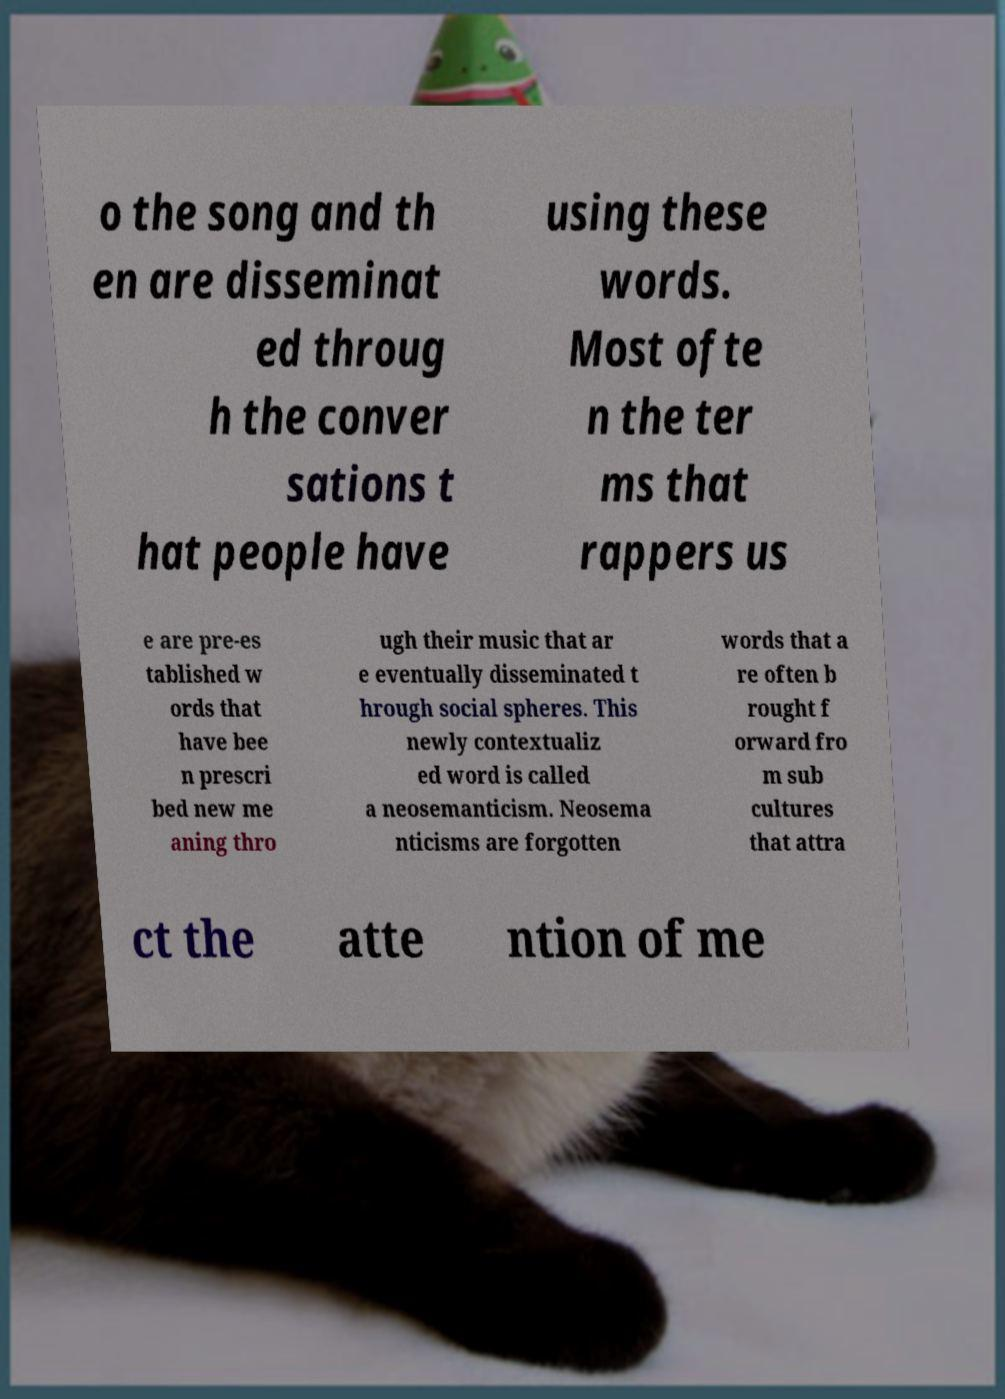For documentation purposes, I need the text within this image transcribed. Could you provide that? o the song and th en are disseminat ed throug h the conver sations t hat people have using these words. Most ofte n the ter ms that rappers us e are pre-es tablished w ords that have bee n prescri bed new me aning thro ugh their music that ar e eventually disseminated t hrough social spheres. This newly contextualiz ed word is called a neosemanticism. Neosema nticisms are forgotten words that a re often b rought f orward fro m sub cultures that attra ct the atte ntion of me 